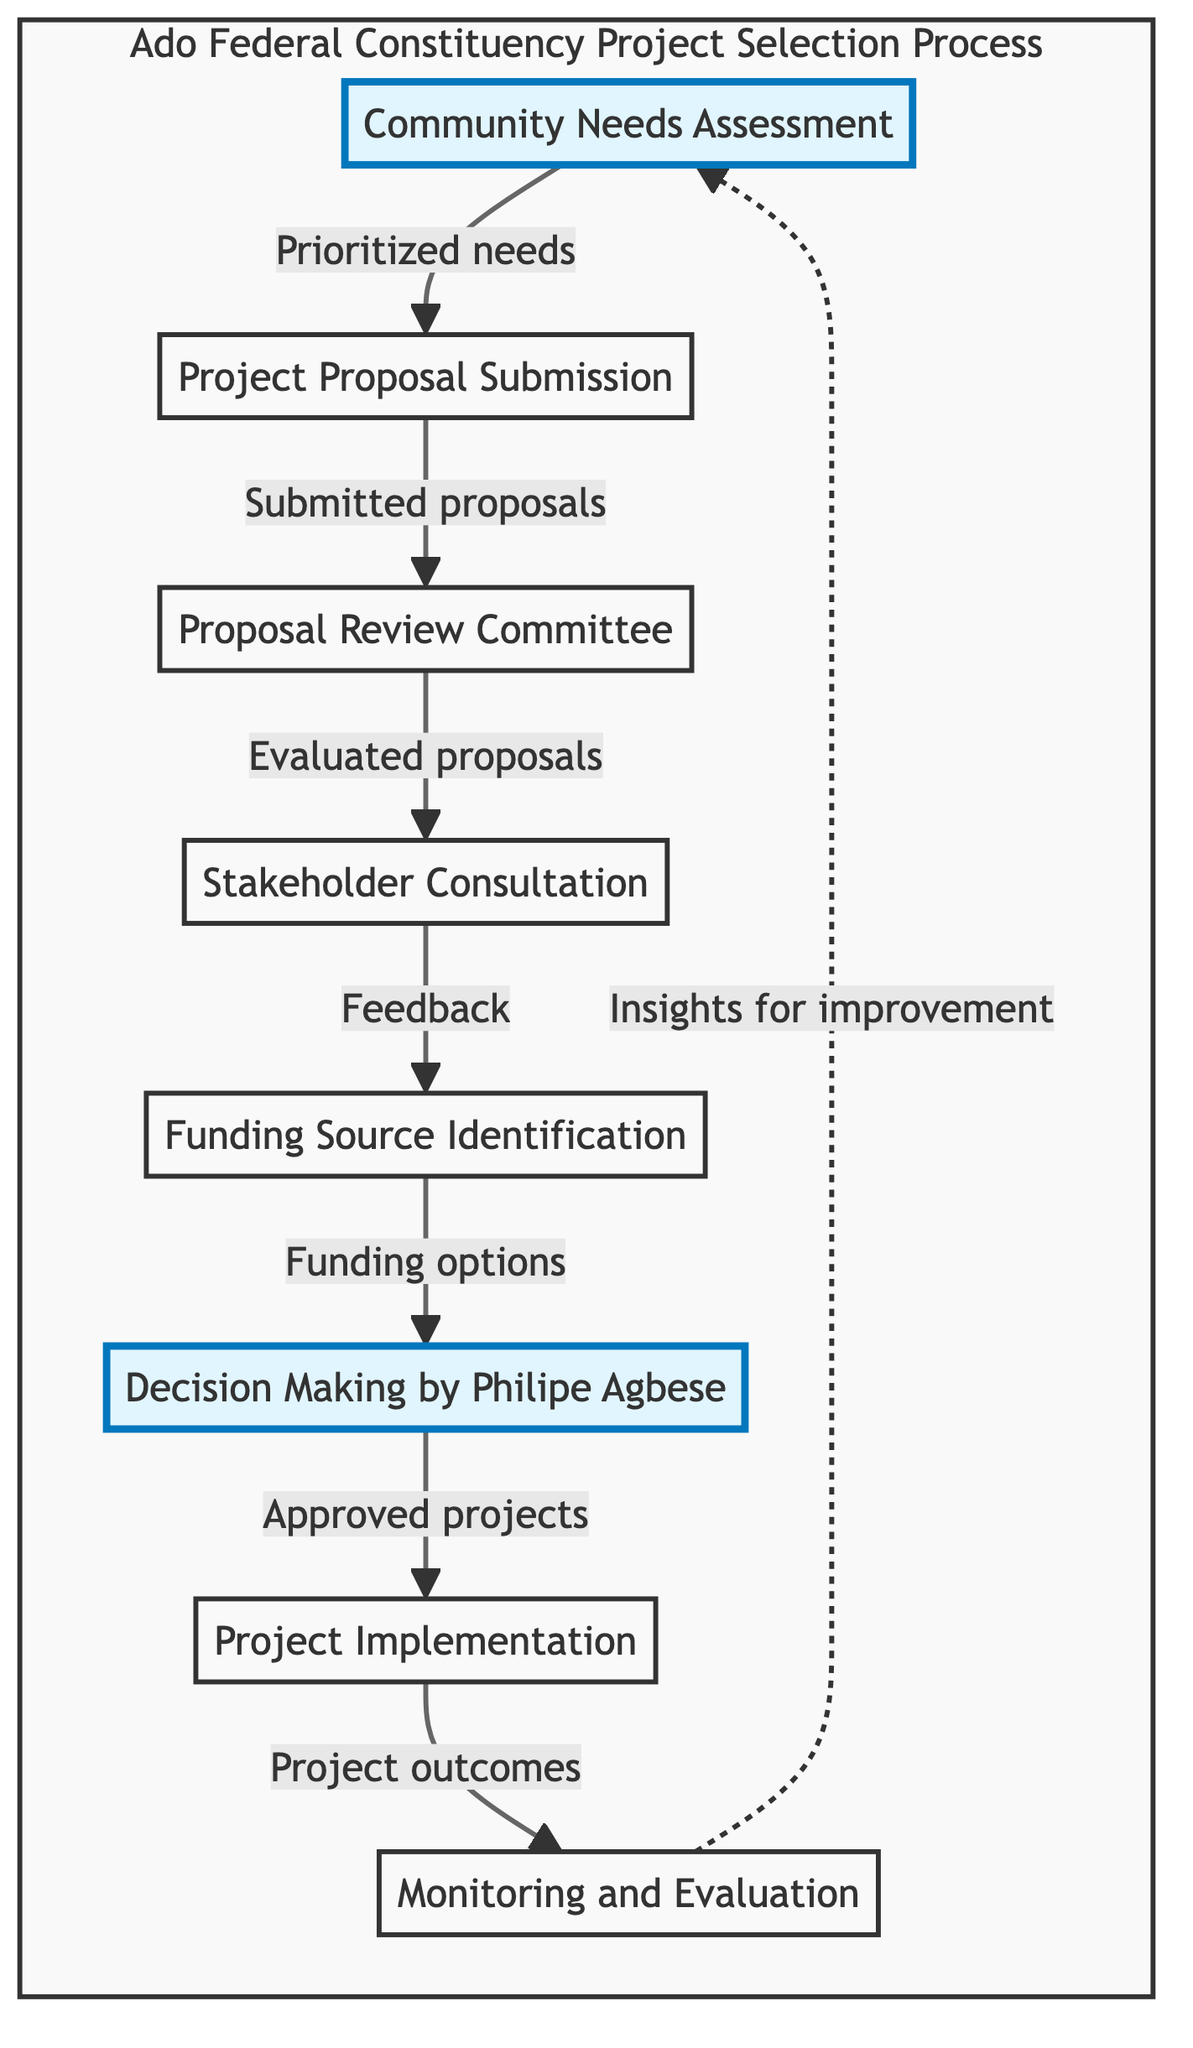What is the first step in the decision-making process? The first step is "Community Needs Assessment" which is represented as the starting node in the flowchart.
Answer: Community Needs Assessment How many total steps are there in the process? The diagram shows a total of eight steps or nodes from "Community Needs Assessment" to "Monitoring and Evaluation".
Answer: Eight What comes after "Project Proposal Submission"? The diagram indicates that "Proposal Review Committee" follows "Project Proposal Submission" as the next step in the process.
Answer: Proposal Review Committee Who makes the final decision on project selection? According to the flowchart, the final decision is made by "Philipe Agbese", as indicated in the corresponding node.
Answer: Philipe Agbese What feedback is sought in the process? The flowchart states that feedback is provided during "Stakeholder Consultation" after proposals have been reviewed, which is essential for project selection.
Answer: Feedback Which node indicates the monitoring stage? The "Monitoring and Evaluation" node signifies the stage where project outcomes are assessed after implementation, as shown at the end of the flowchart.
Answer: Monitoring and Evaluation What nodes are directly connected to "Funding Source Identification"? The diagram shows that "Funding Source Identification" is connected to "Stakeholder Consultation" before it and "Decision Making by Philipe Agbese" after it, indicating a flow of information regarding funding for selected projects.
Answer: Stakeholder Consultation, Decision Making by Philipe Agbese What is the feedback loop in the flowchart? The feedback loop involves evaluating project outcomes in "Monitoring and Evaluation", which leads back to "Community Needs Assessment" for insights on improvement, demonstrating that the process is cyclical.
Answer: Insights for improvement How are project proposals evaluated? Proposals are evaluated by the "Proposal Review Committee" based on feasibility, impact, and resource availability as per the description in the flowchart.
Answer: Proposal Review Committee 